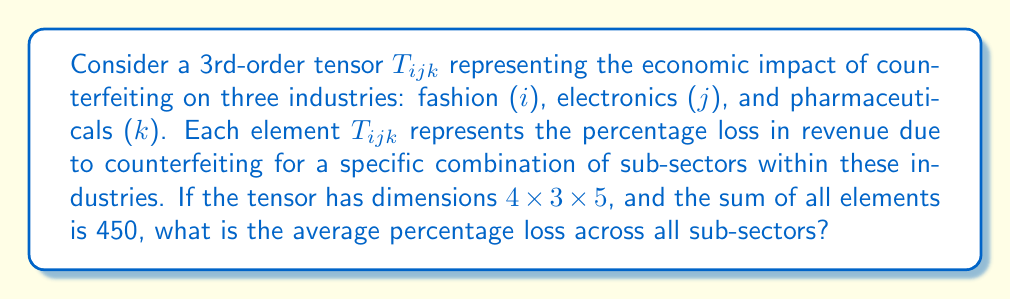Give your solution to this math problem. To solve this problem, we'll follow these steps:

1) First, let's understand what the dimensions of the tensor mean:
   - 4 sub-sectors in the fashion industry (i)
   - 3 sub-sectors in the electronics industry (j)
   - 5 sub-sectors in the pharmaceutical industry (k)

2) The total number of elements in the tensor is:
   $$ 4 \times 3 \times 5 = 60 $$

3) We're given that the sum of all elements is 450. This represents the total percentage loss across all sub-sectors of all industries.

4) To find the average percentage loss, we need to divide the total loss by the number of elements:

   $$ \text{Average Loss} = \frac{\text{Total Loss}}{\text{Number of Elements}} = \frac{450}{60} = 7.5 $$

5) Therefore, the average percentage loss across all sub-sectors is 7.5%.

This result gives the business owner an idea of the average impact of counterfeiting across multiple industries, helping to contextualize the issue and potentially guide anti-counterfeiting strategies.
Answer: 7.5% 